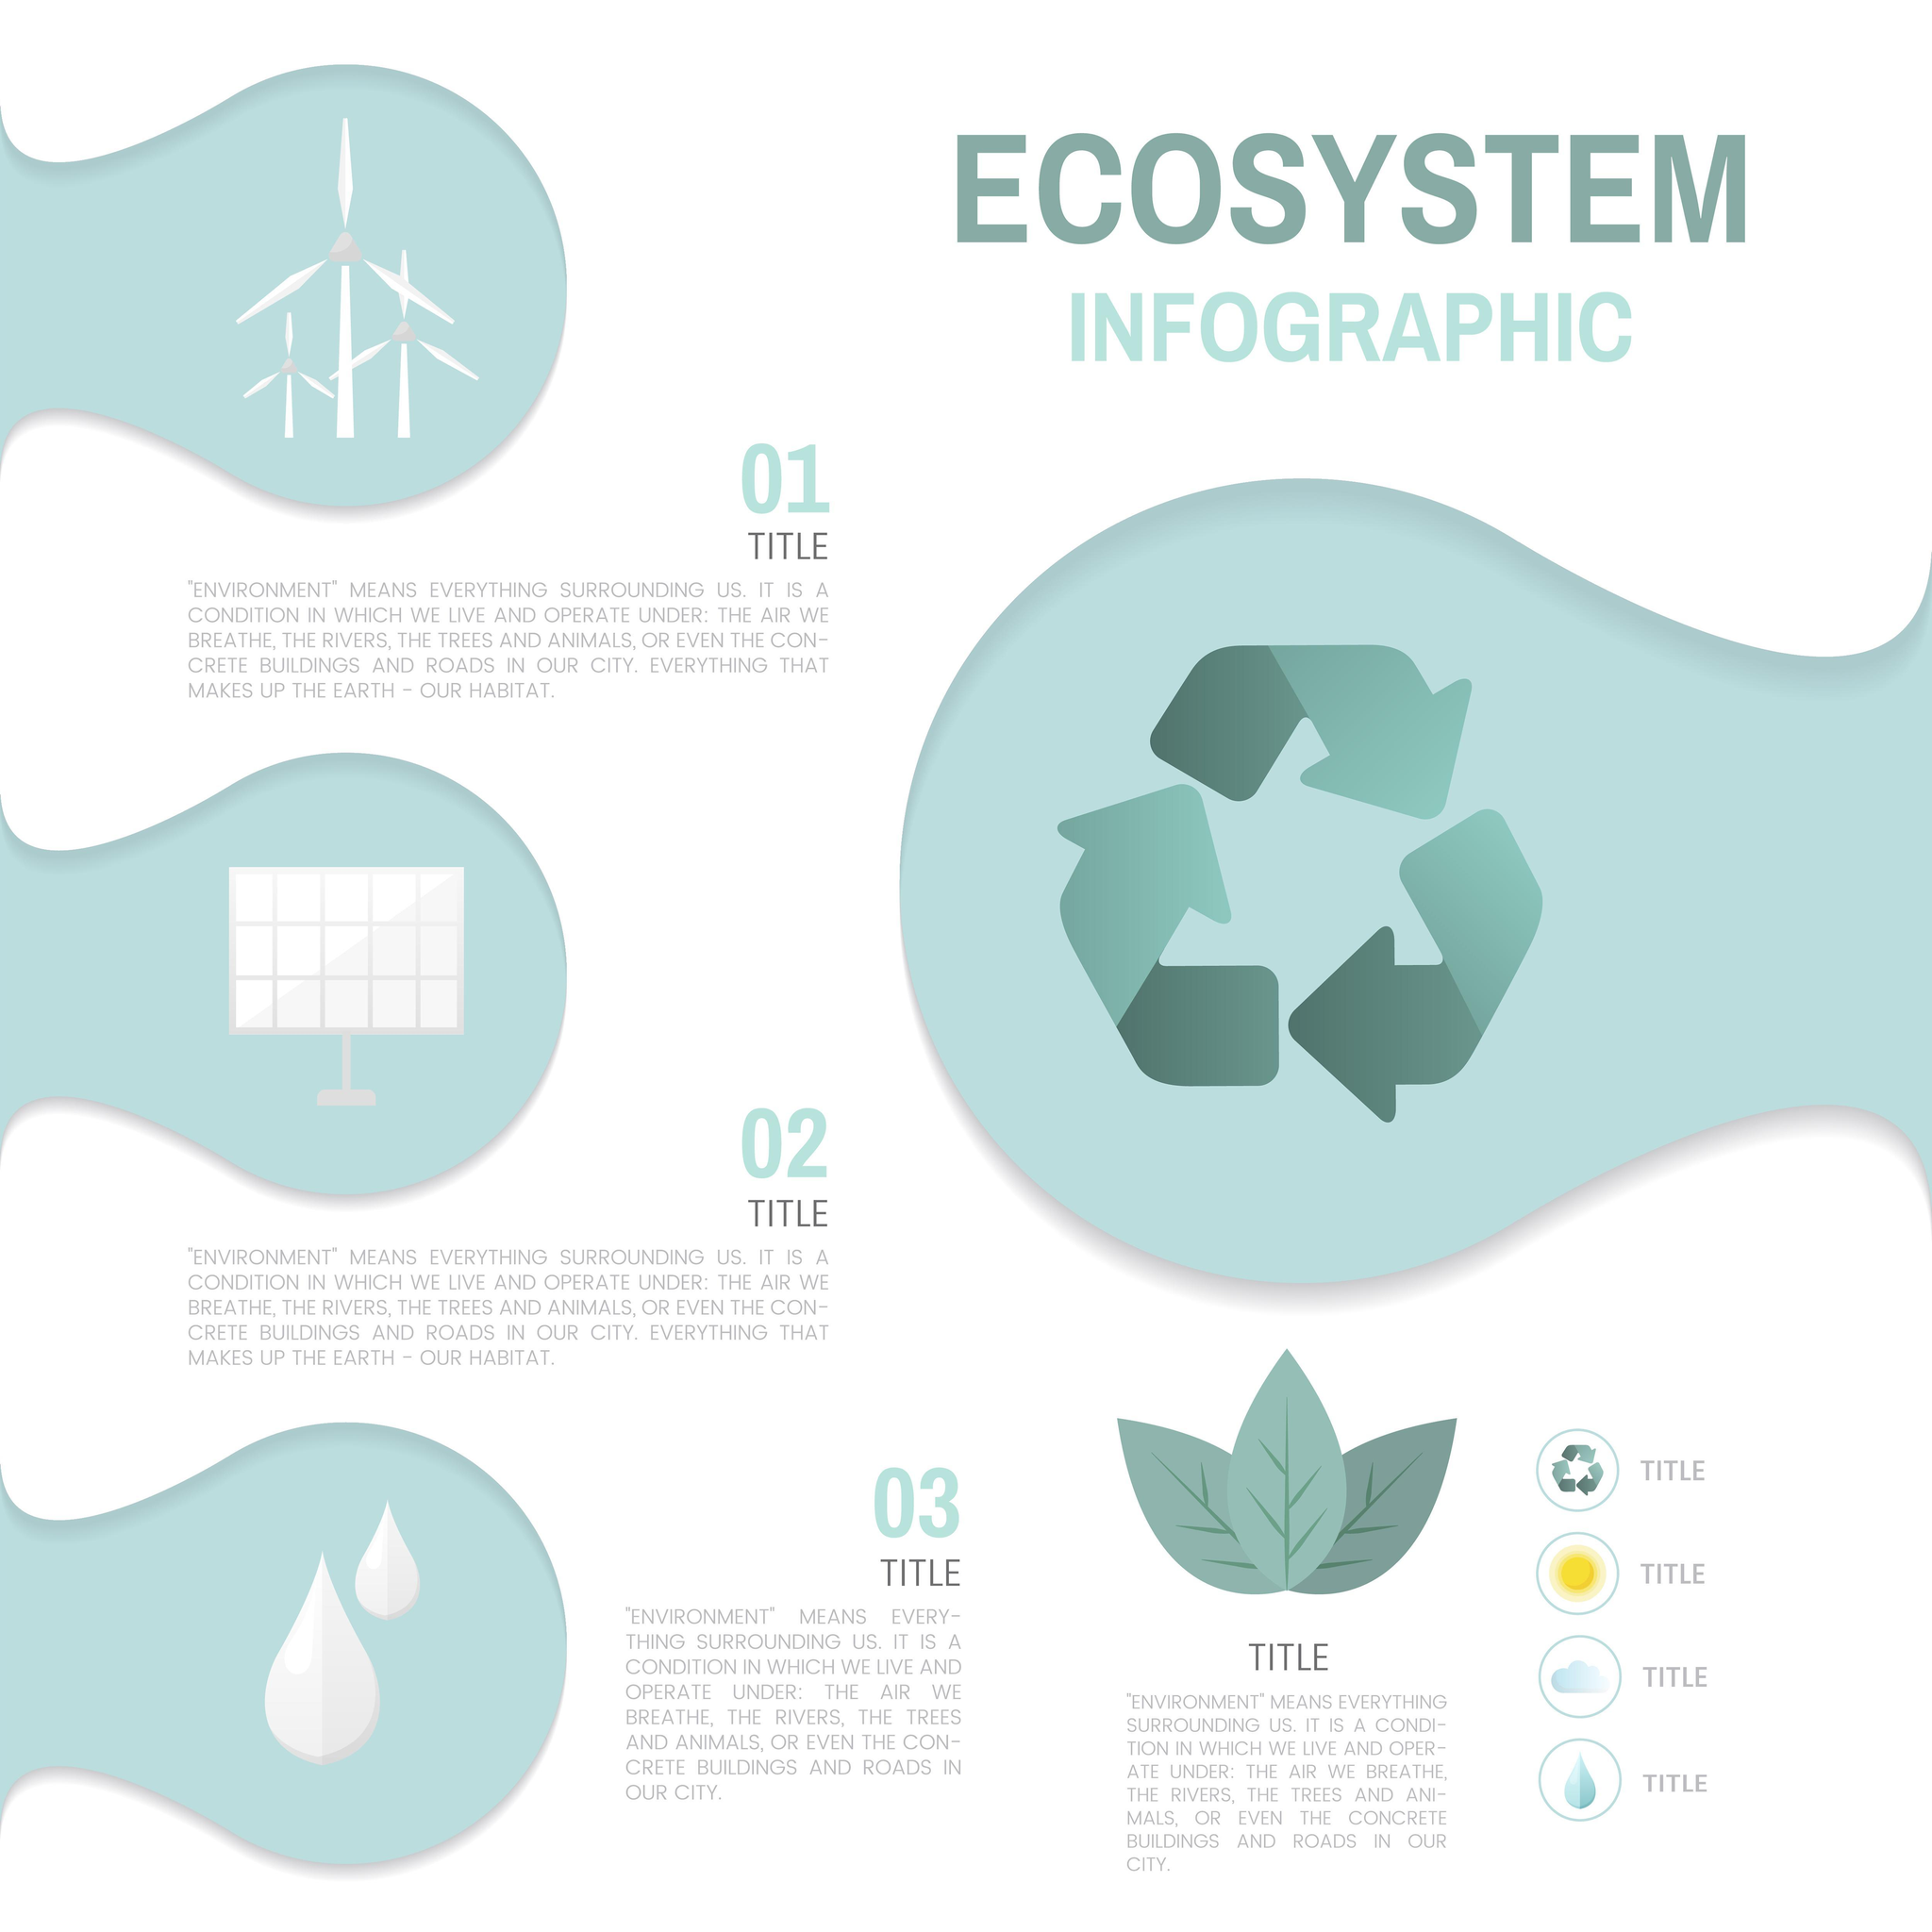Which symbol used to represent "Title 3"-sun, water drops, sun?
Answer the question with a short phrase. water drops 